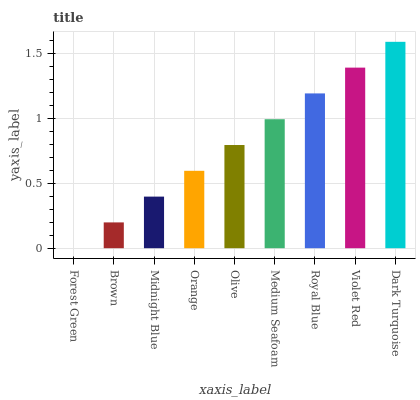Is Forest Green the minimum?
Answer yes or no. Yes. Is Dark Turquoise the maximum?
Answer yes or no. Yes. Is Brown the minimum?
Answer yes or no. No. Is Brown the maximum?
Answer yes or no. No. Is Brown greater than Forest Green?
Answer yes or no. Yes. Is Forest Green less than Brown?
Answer yes or no. Yes. Is Forest Green greater than Brown?
Answer yes or no. No. Is Brown less than Forest Green?
Answer yes or no. No. Is Olive the high median?
Answer yes or no. Yes. Is Olive the low median?
Answer yes or no. Yes. Is Violet Red the high median?
Answer yes or no. No. Is Forest Green the low median?
Answer yes or no. No. 